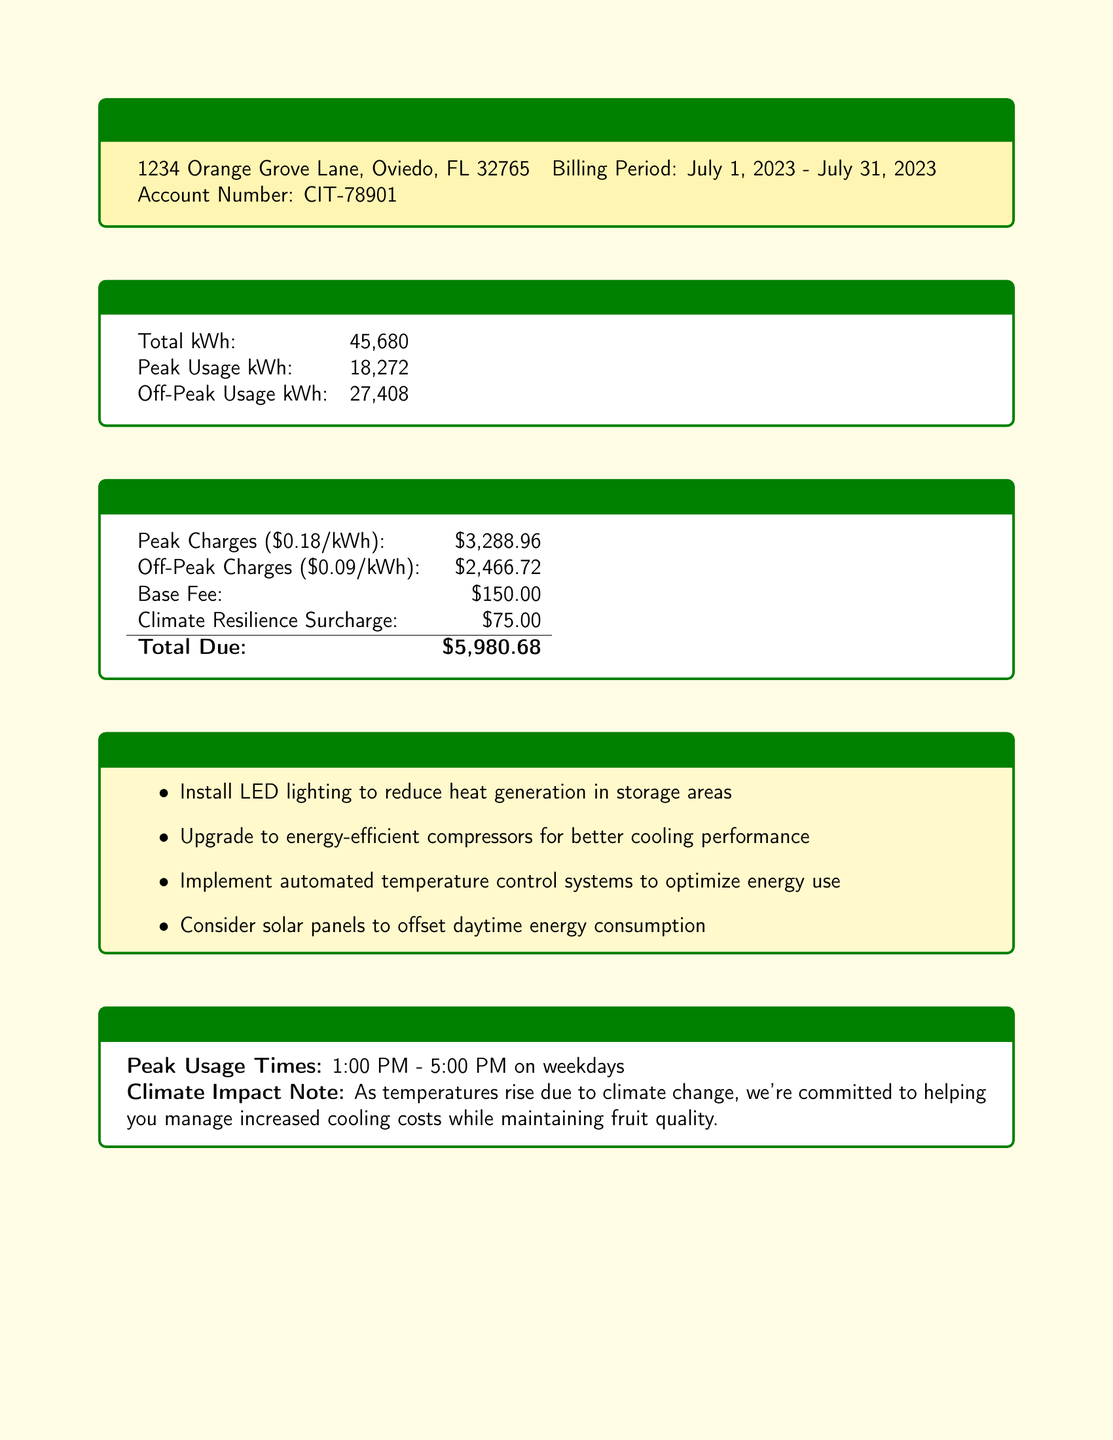what is the total energy consumption in kWh? The total energy consumption is explicitly stated in the bill.
Answer: 45,680 what is the peak usage in kWh? Peak usage is a specific measurement mentioned in the document.
Answer: 18,272 what is the off-peak usage in kWh? Off-peak usage is also specified in the energy consumption section of the bill.
Answer: 27,408 what is the total amount due? The total amount due is calculated from various charges listed in the document.
Answer: $5,980.68 what are the peak usage times? The peak usage times are clearly outlined in the important information section.
Answer: 1:00 PM - 5:00 PM on weekdays how much is the base fee? The base fee is listed in the charges section of the document.
Answer: $150.00 what is one efficiency recommendation mentioned? The efficiency recommendations can be found in their own section and suggest actions to improve energy use.
Answer: Install LED lighting to reduce heat generation in storage areas what is the climate resilience surcharge amount? The climate resilience surcharge is specifically noted in the charges section of the document.
Answer: $75.00 how can I pay my bill online? Payment options are provided, explaining how to pay online, by phone, or by mail.
Answer: www.sunburstcoldstorage.com/pay 